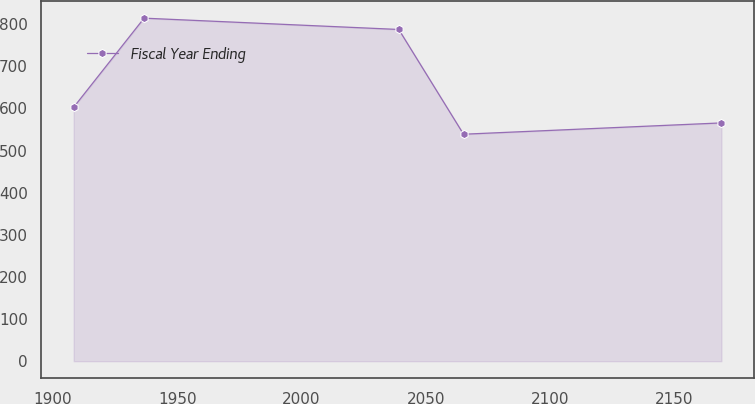Convert chart to OTSL. <chart><loc_0><loc_0><loc_500><loc_500><line_chart><ecel><fcel>Fiscal Year Ending<nl><fcel>1908.34<fcel>602.89<nl><fcel>1936.67<fcel>814.36<nl><fcel>2039.15<fcel>787.49<nl><fcel>2065.21<fcel>538.81<nl><fcel>2168.98<fcel>565.68<nl></chart> 